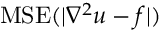<formula> <loc_0><loc_0><loc_500><loc_500>M S E ( | \nabla ^ { 2 } u - f | )</formula> 